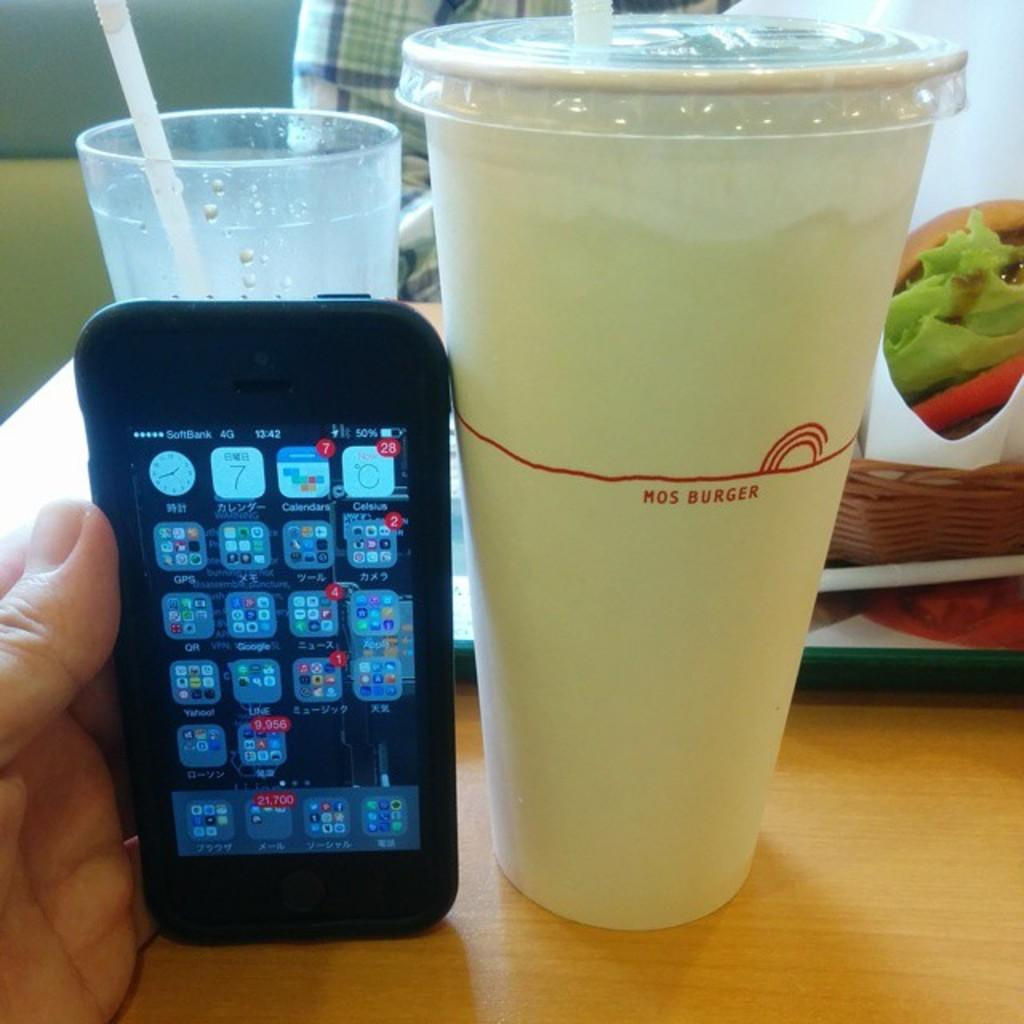<image>
Write a terse but informative summary of the picture. A Mos Burger drink cup is being compared to an iphone for scale. 